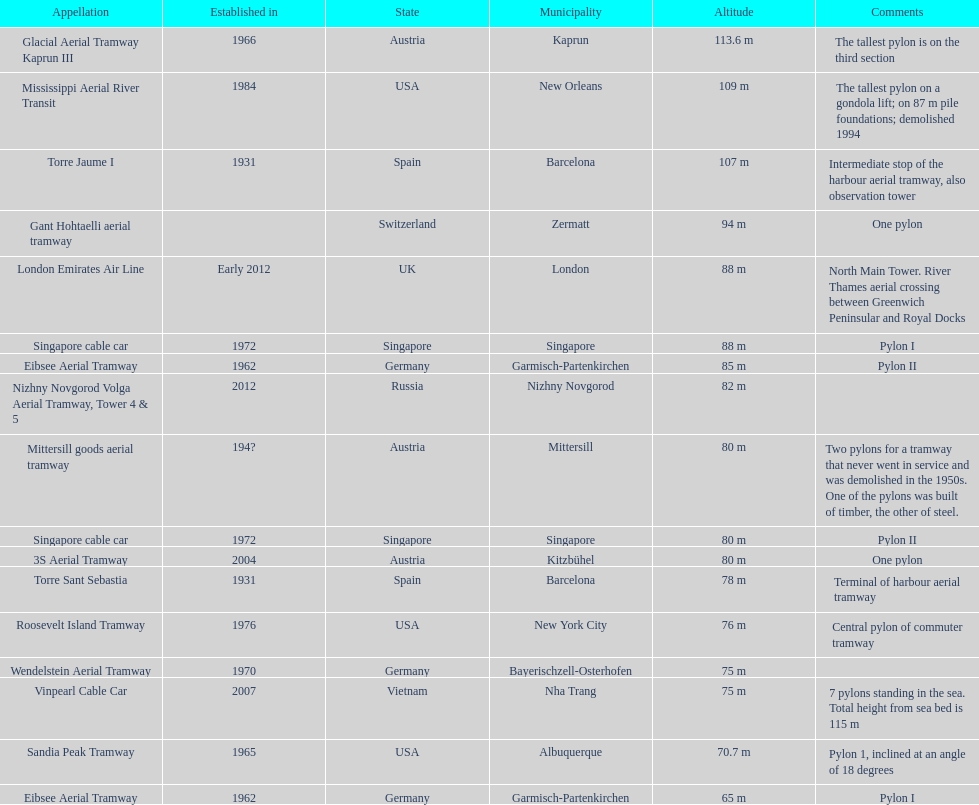The london emirates air line pylon has the same height as which pylon? Singapore cable car. 